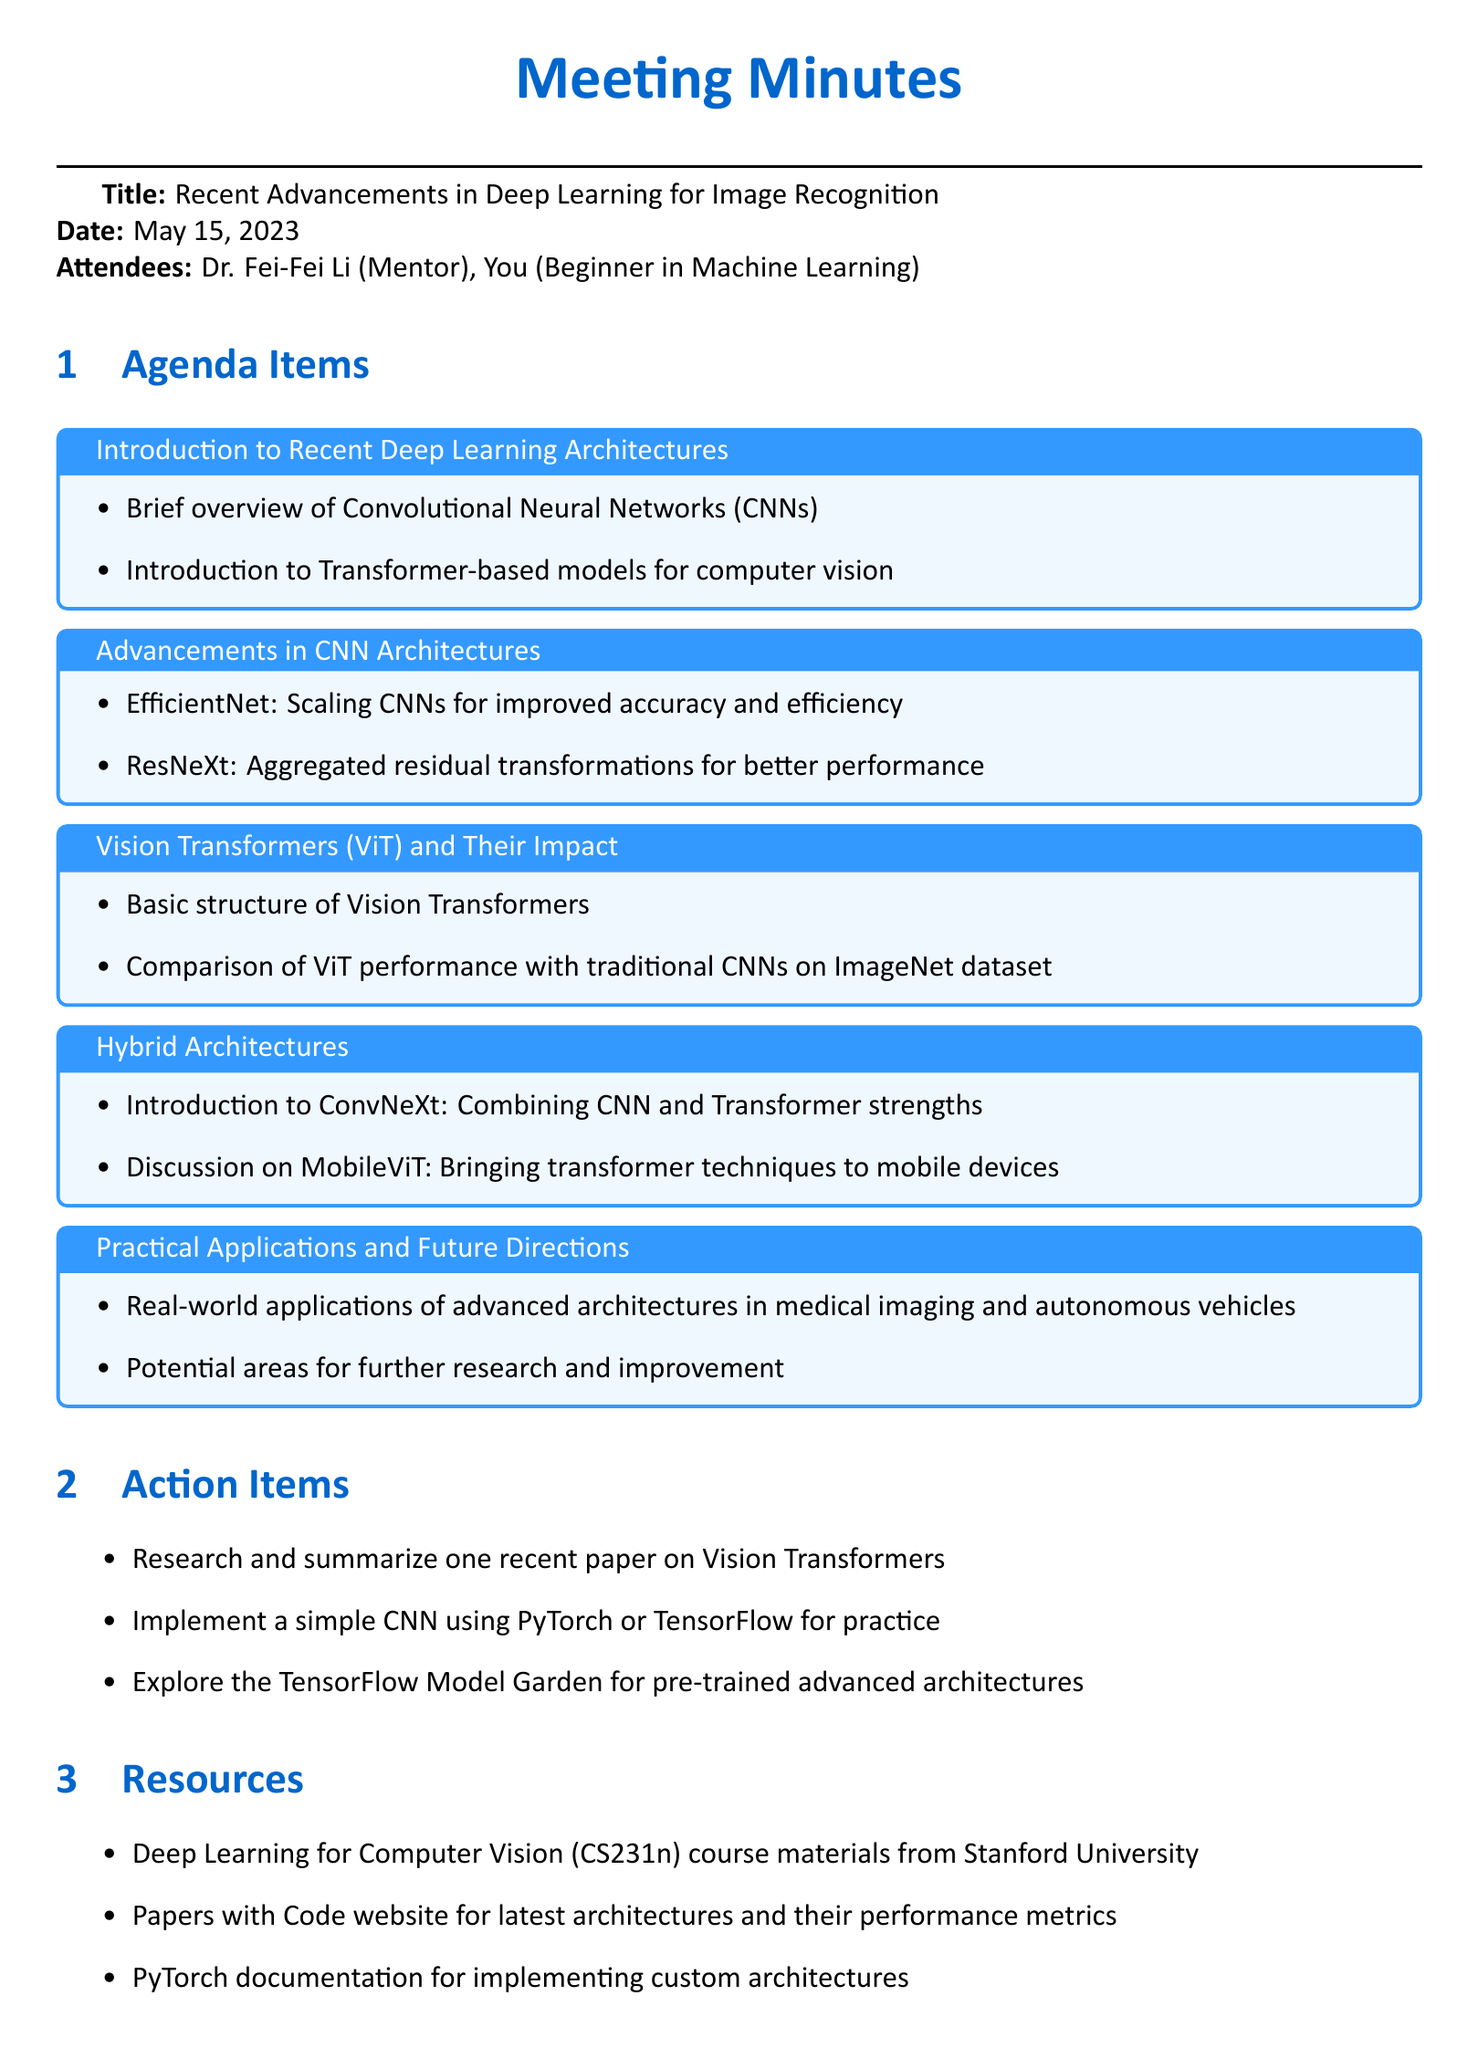What is the meeting title? The meeting title is explicitly stated in the document as the main focus of the meeting minutes.
Answer: Recent Advancements in Deep Learning for Image Recognition Who attended the meeting? The document lists the names of the attendees under the "Attendees" section.
Answer: Dr. Fei-Fei Li (Mentor), You (Beginner in Machine Learning) When was the meeting held? The date of the meeting is provided in the first part of the document.
Answer: May 15, 2023 What is one of the advanced CNN architectures mentioned? The key points under the "Advancements in CNN Architectures" section specifically list architectures.
Answer: EfficientNet What real-world application of advanced architectures is discussed? The document mentions practical applications in the final section known for their relevance to current trends.
Answer: Medical imaging Which architecture combines CNN and Transformer strengths? The document specifically discusses a hybrid architecture in the relevant section.
Answer: ConvNeXt What is one action item from the meeting? Action items are clearly listed in their dedicated section of the document.
Answer: Research and summarize one recent paper on Vision Transformers What resource is recommended in the meeting? Resources are provided as a list at the end, meant to aid further learning.
Answer: Deep Learning for Computer Vision (CS231n) course materials from Stanford University Which architecture is discussed in relation to mobile devices? The section on hybrid architectures mentions a specific architecture targeting mobile applications.
Answer: MobileViT 